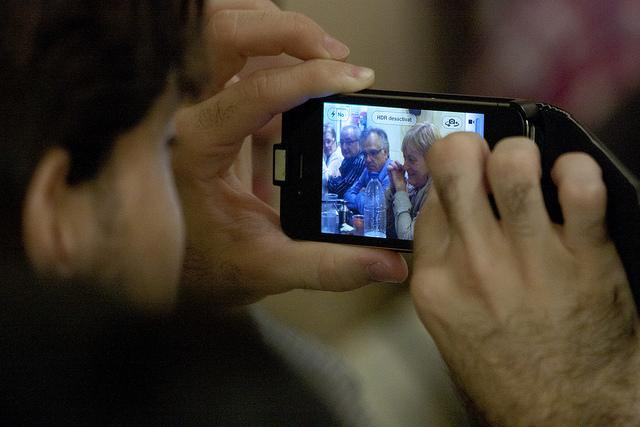Which is magnifying or moving towards yourself the photography is called? Please explain your reasoning. zoom. The term zoom is used when looking closer at an object. 